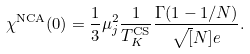<formula> <loc_0><loc_0><loc_500><loc_500>\chi ^ { \text {\text {NCA}} } ( 0 ) = \frac { 1 } { 3 } \mu _ { j } ^ { 2 } \frac { 1 } { T _ { K } ^ { \text {CS} } } \frac { \Gamma ( 1 - 1 / N ) } { \sqrt { [ } N ] { e } } .</formula> 